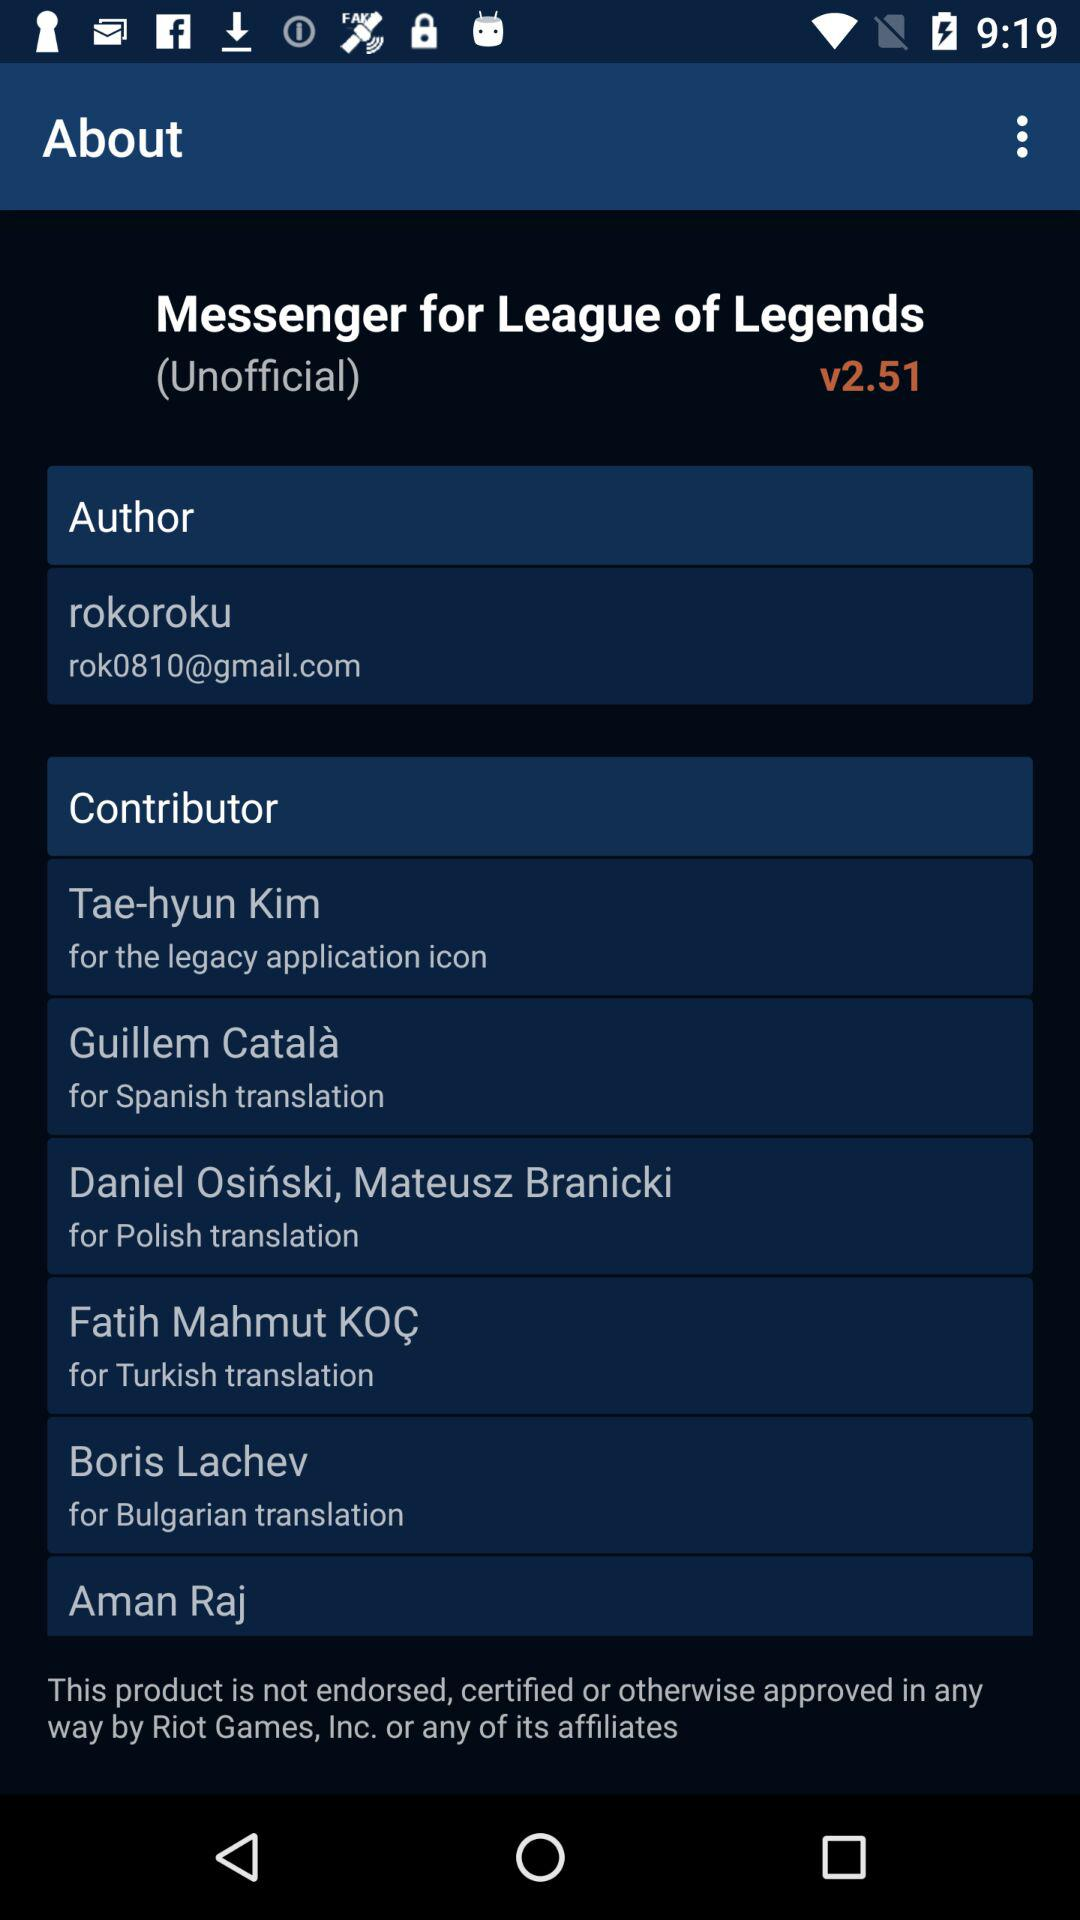How many contributors have a Spanish translation?
Answer the question using a single word or phrase. 1 